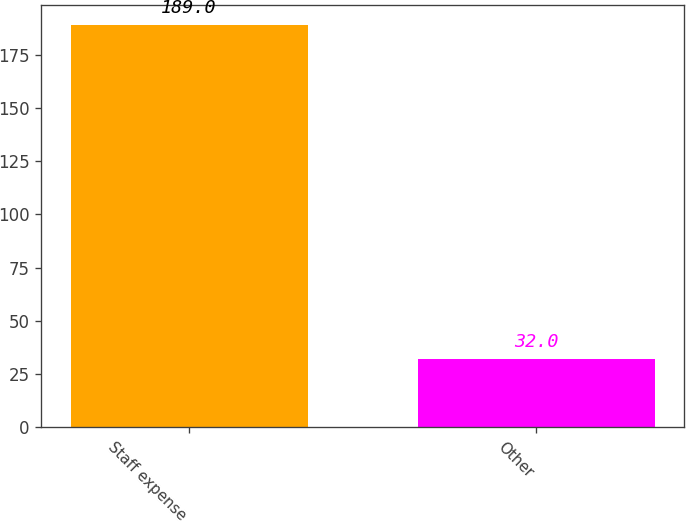<chart> <loc_0><loc_0><loc_500><loc_500><bar_chart><fcel>Staff expense<fcel>Other<nl><fcel>189<fcel>32<nl></chart> 